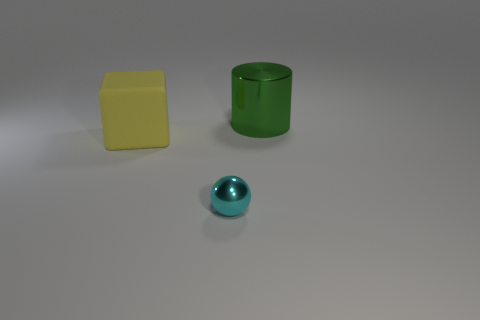Add 3 tiny gray cylinders. How many objects exist? 6 Add 2 metal things. How many metal things exist? 4 Subtract 0 gray balls. How many objects are left? 3 Subtract all cubes. How many objects are left? 2 Subtract all cyan metal spheres. Subtract all cyan metal cylinders. How many objects are left? 2 Add 2 big blocks. How many big blocks are left? 3 